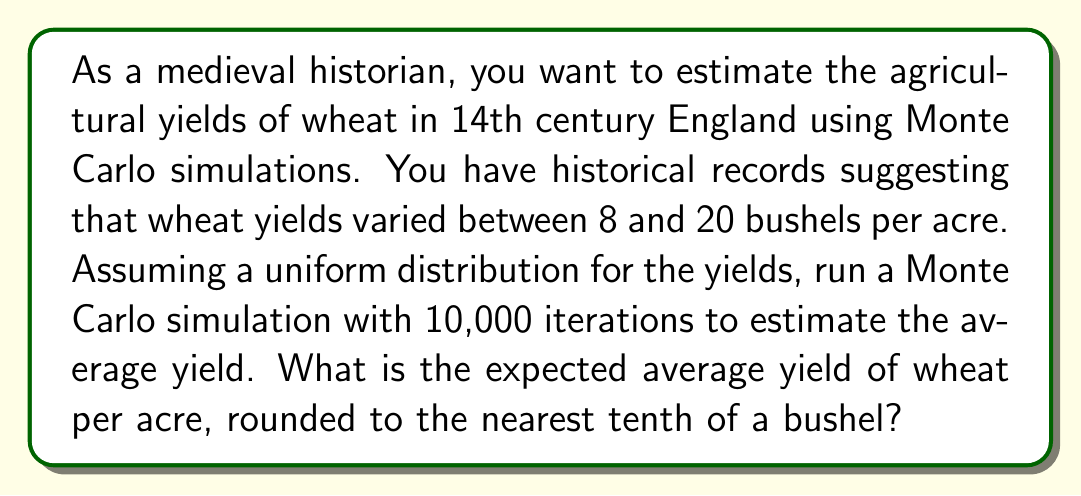Teach me how to tackle this problem. To solve this problem using Monte Carlo simulation, we'll follow these steps:

1) Set up the simulation:
   - We assume a uniform distribution between 8 and 20 bushels per acre.
   - We'll run 10,000 iterations.

2) Generate random samples:
   For each iteration, we generate a random number $x_i$ from the uniform distribution:
   $$x_i = 8 + (20 - 8) * \text{random}(0,1)$$
   where $\text{random}(0,1)$ is a random number between 0 and 1.

3) Calculate the average:
   After generating all samples, we calculate the average:
   $$\bar{x} = \frac{1}{n}\sum_{i=1}^n x_i$$
   where $n = 10000$ is the number of iterations.

4) For a uniform distribution, the theoretical expected value is:
   $$E(X) = \frac{a + b}{2}$$
   where $a$ is the minimum value and $b$ is the maximum value.

5) In this case:
   $$E(X) = \frac{8 + 20}{2} = 14$$

6) The Monte Carlo simulation should converge to this theoretical value as the number of iterations increases.

7) Rounding to the nearest tenth:
   The result should be very close to 14.0 bushels per acre.
Answer: 14.0 bushels per acre 